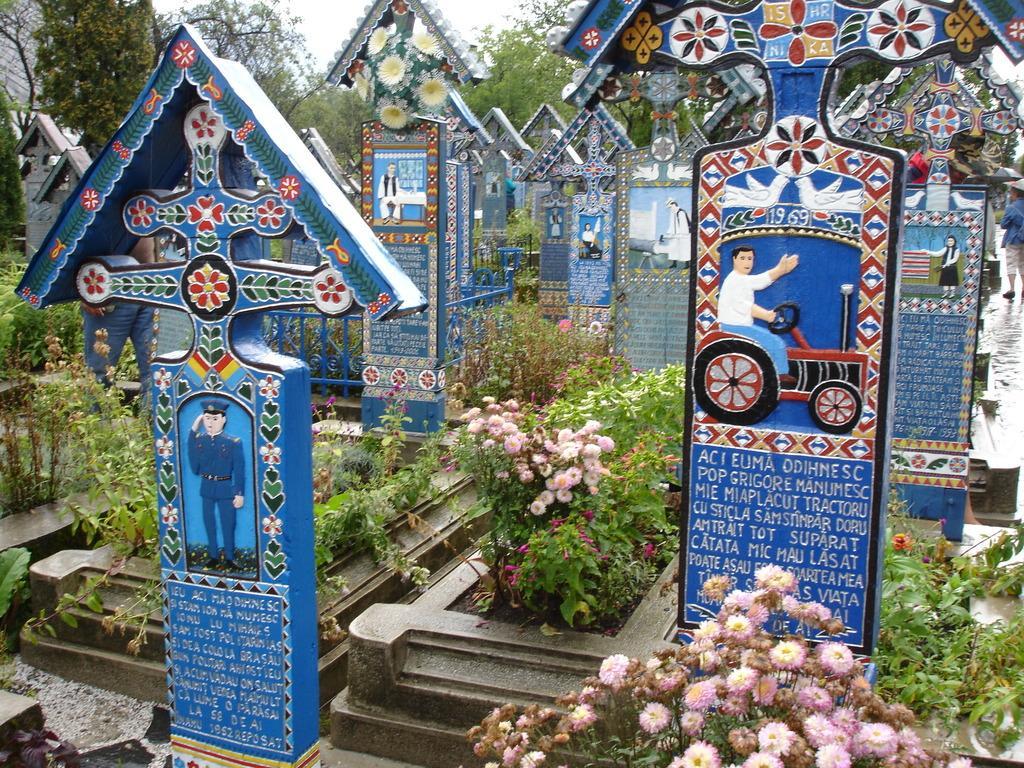Could you give a brief overview of what you see in this image? In this image, we can see cemeteries, few plants and flowers. Top of the image, we can see trees, wall and sky. 